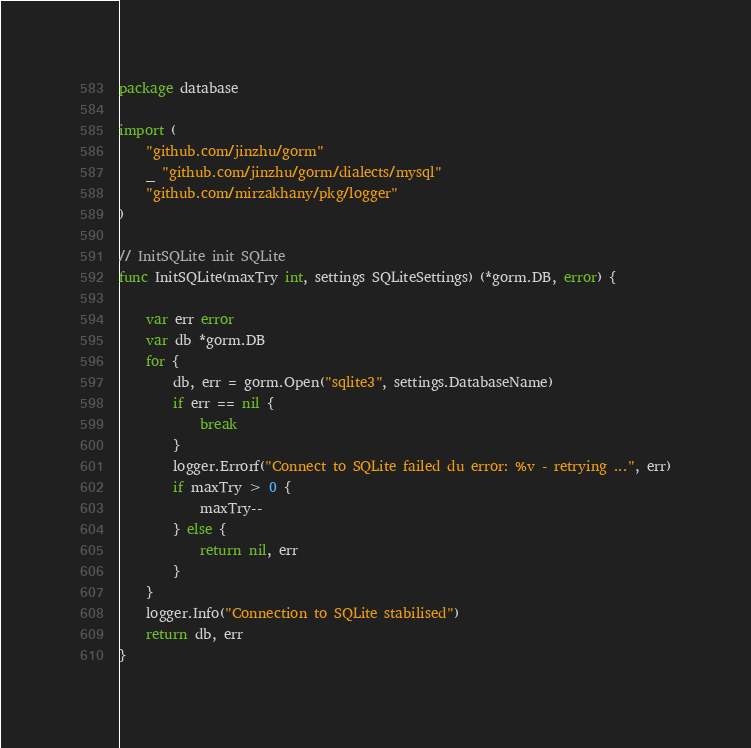Convert code to text. <code><loc_0><loc_0><loc_500><loc_500><_Go_>package database

import (
	"github.com/jinzhu/gorm"
	_ "github.com/jinzhu/gorm/dialects/mysql"
	"github.com/mirzakhany/pkg/logger"
)

// InitSQLite init SQLite
func InitSQLite(maxTry int, settings SQLiteSettings) (*gorm.DB, error) {

	var err error
	var db *gorm.DB
	for {
		db, err = gorm.Open("sqlite3", settings.DatabaseName)
		if err == nil {
			break
		}
		logger.Errorf("Connect to SQLite failed du error: %v - retrying ...", err)
		if maxTry > 0 {
			maxTry--
		} else {
			return nil, err
		}
	}
	logger.Info("Connection to SQLite stabilised")
	return db, err
}
</code> 